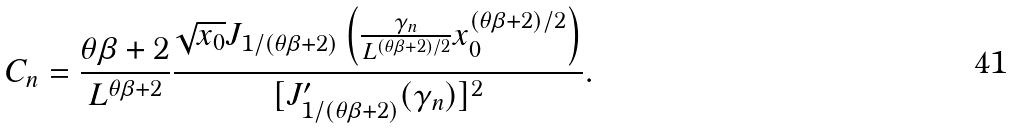Convert formula to latex. <formula><loc_0><loc_0><loc_500><loc_500>C _ { n } = \frac { \theta \beta + 2 } { L ^ { \theta \beta + 2 } } \frac { \sqrt { x _ { 0 } } J _ { 1 / ( \theta \beta + 2 ) } \left ( \frac { \gamma _ { n } } { L ^ { ( \theta \beta + 2 ) / 2 } } x _ { 0 } ^ { ( \theta \beta + 2 ) / 2 } \right ) } { [ J ^ { \prime } _ { 1 / ( \theta \beta + 2 ) } ( \gamma _ { n } ) ] ^ { 2 } } .</formula> 